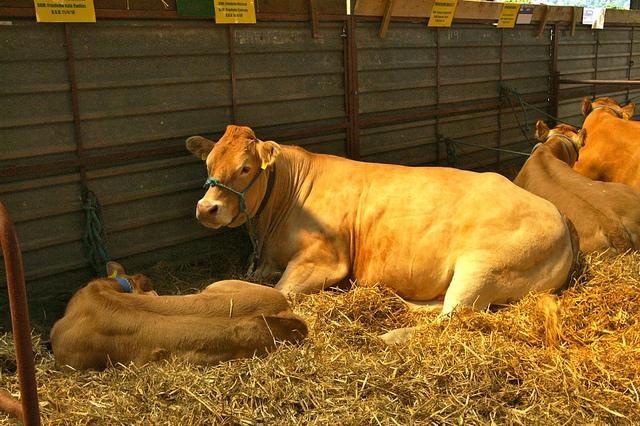Does the calf second-closest to the camera have anything around its muzzle?
Quick response, please. Yes. How many calves are in the barn?
Quick response, please. 1. Is there straw in the barn?
Concise answer only. Yes. 